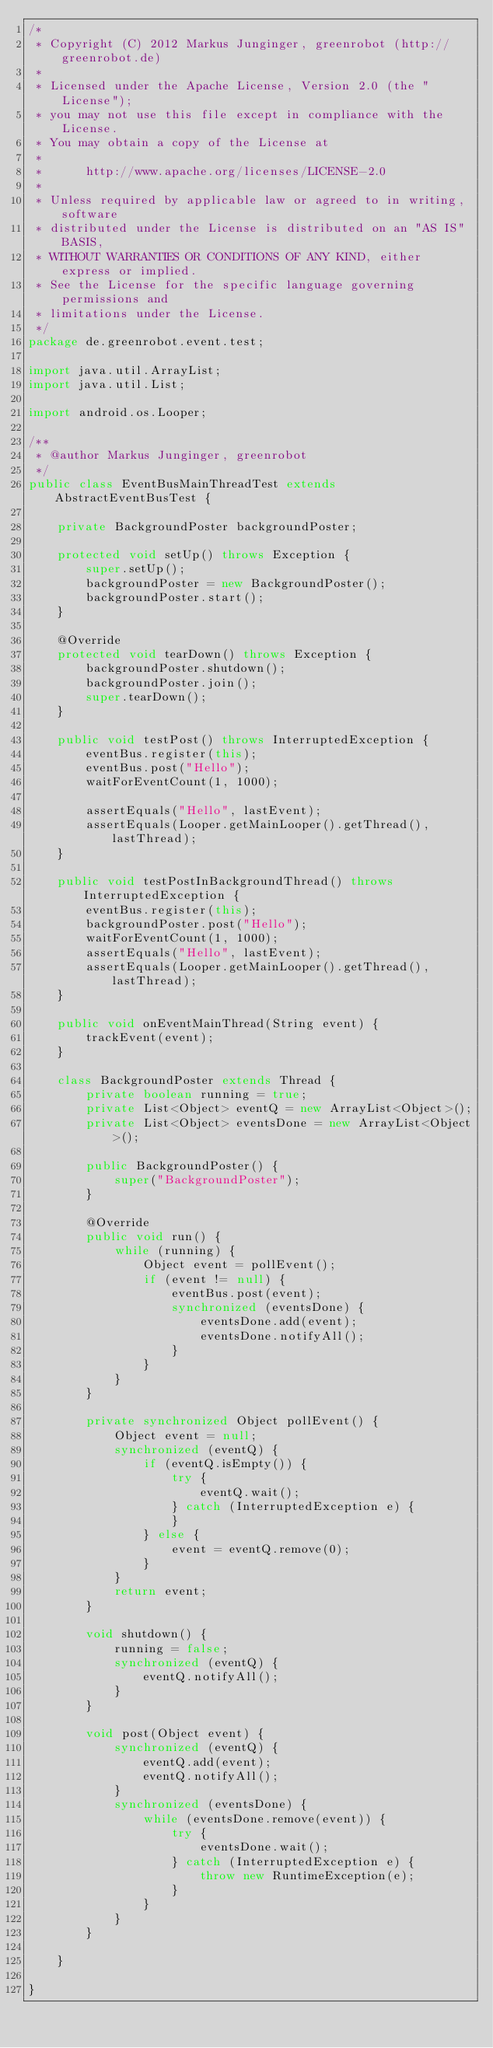<code> <loc_0><loc_0><loc_500><loc_500><_Java_>/*
 * Copyright (C) 2012 Markus Junginger, greenrobot (http://greenrobot.de)
 *
 * Licensed under the Apache License, Version 2.0 (the "License");
 * you may not use this file except in compliance with the License.
 * You may obtain a copy of the License at
 *
 *      http://www.apache.org/licenses/LICENSE-2.0
 *
 * Unless required by applicable law or agreed to in writing, software
 * distributed under the License is distributed on an "AS IS" BASIS,
 * WITHOUT WARRANTIES OR CONDITIONS OF ANY KIND, either express or implied.
 * See the License for the specific language governing permissions and
 * limitations under the License.
 */
package de.greenrobot.event.test;

import java.util.ArrayList;
import java.util.List;

import android.os.Looper;

/**
 * @author Markus Junginger, greenrobot
 */
public class EventBusMainThreadTest extends AbstractEventBusTest {

    private BackgroundPoster backgroundPoster;

    protected void setUp() throws Exception {
        super.setUp();
        backgroundPoster = new BackgroundPoster();
        backgroundPoster.start();
    }

    @Override
    protected void tearDown() throws Exception {
        backgroundPoster.shutdown();
        backgroundPoster.join();
        super.tearDown();
    }

    public void testPost() throws InterruptedException {
        eventBus.register(this);
        eventBus.post("Hello");
        waitForEventCount(1, 1000);

        assertEquals("Hello", lastEvent);
        assertEquals(Looper.getMainLooper().getThread(), lastThread);
    }

    public void testPostInBackgroundThread() throws InterruptedException {
        eventBus.register(this);
        backgroundPoster.post("Hello");
        waitForEventCount(1, 1000);
        assertEquals("Hello", lastEvent);
        assertEquals(Looper.getMainLooper().getThread(), lastThread);
    }

    public void onEventMainThread(String event) {
        trackEvent(event);
    }

    class BackgroundPoster extends Thread {
        private boolean running = true;
        private List<Object> eventQ = new ArrayList<Object>();
        private List<Object> eventsDone = new ArrayList<Object>();

        public BackgroundPoster() {
            super("BackgroundPoster");
        }

        @Override
        public void run() {
            while (running) {
                Object event = pollEvent();
                if (event != null) {
                    eventBus.post(event);
                    synchronized (eventsDone) {
                        eventsDone.add(event);
                        eventsDone.notifyAll();
                    }
                }
            }
        }

        private synchronized Object pollEvent() {
            Object event = null;
            synchronized (eventQ) {
                if (eventQ.isEmpty()) {
                    try {
                        eventQ.wait();
                    } catch (InterruptedException e) {
                    }
                } else {
                    event = eventQ.remove(0);
                }
            }
            return event;
        }

        void shutdown() {
            running = false;
            synchronized (eventQ) {
                eventQ.notifyAll();
            }
        }

        void post(Object event) {
            synchronized (eventQ) {
                eventQ.add(event);
                eventQ.notifyAll();
            }
            synchronized (eventsDone) {
                while (eventsDone.remove(event)) {
                    try {
                        eventsDone.wait();
                    } catch (InterruptedException e) {
                        throw new RuntimeException(e);
                    }
                }
            }
        }

    }

}
</code> 